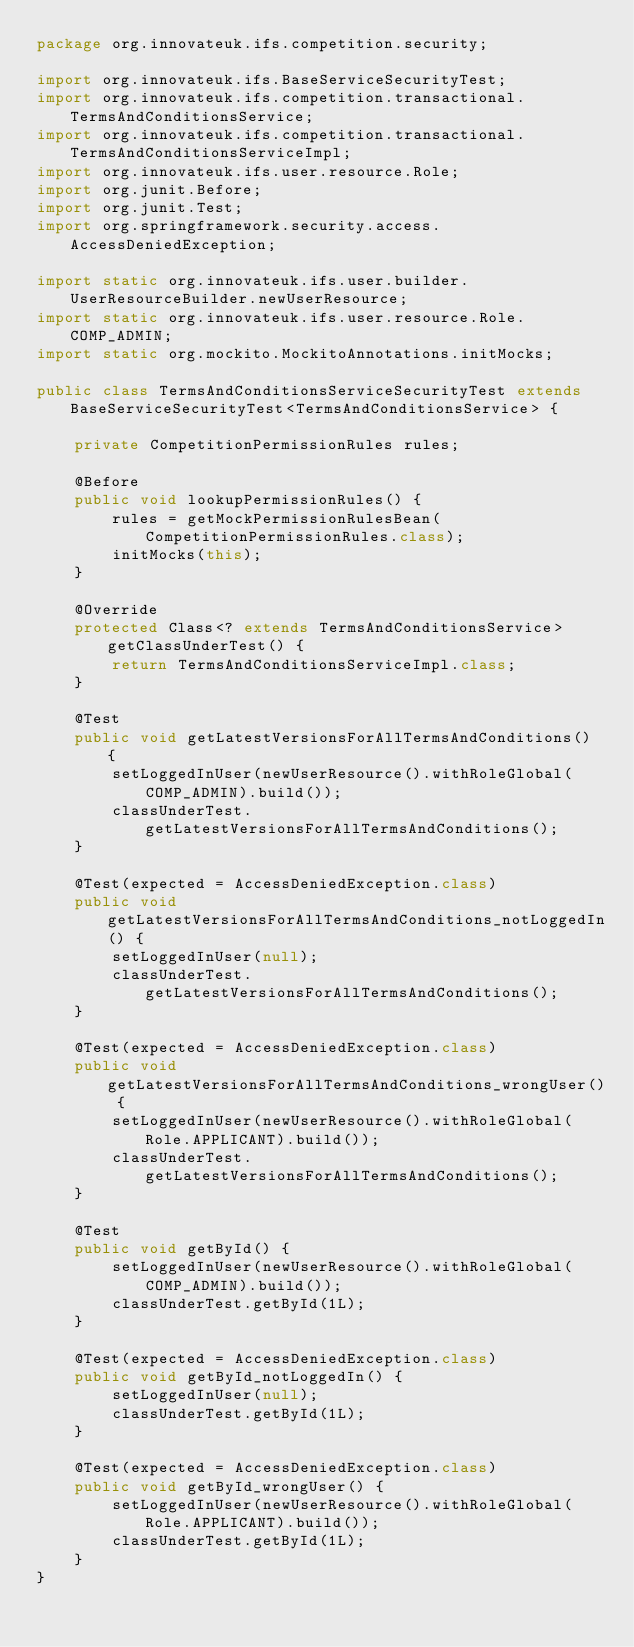<code> <loc_0><loc_0><loc_500><loc_500><_Java_>package org.innovateuk.ifs.competition.security;

import org.innovateuk.ifs.BaseServiceSecurityTest;
import org.innovateuk.ifs.competition.transactional.TermsAndConditionsService;
import org.innovateuk.ifs.competition.transactional.TermsAndConditionsServiceImpl;
import org.innovateuk.ifs.user.resource.Role;
import org.junit.Before;
import org.junit.Test;
import org.springframework.security.access.AccessDeniedException;

import static org.innovateuk.ifs.user.builder.UserResourceBuilder.newUserResource;
import static org.innovateuk.ifs.user.resource.Role.COMP_ADMIN;
import static org.mockito.MockitoAnnotations.initMocks;

public class TermsAndConditionsServiceSecurityTest extends BaseServiceSecurityTest<TermsAndConditionsService> {

    private CompetitionPermissionRules rules;

    @Before
    public void lookupPermissionRules() {
        rules = getMockPermissionRulesBean(CompetitionPermissionRules.class);
        initMocks(this);
    }

    @Override
    protected Class<? extends TermsAndConditionsService> getClassUnderTest() {
        return TermsAndConditionsServiceImpl.class;
    }

    @Test
    public void getLatestVersionsForAllTermsAndConditions() {
        setLoggedInUser(newUserResource().withRoleGlobal(COMP_ADMIN).build());
        classUnderTest.getLatestVersionsForAllTermsAndConditions();
    }

    @Test(expected = AccessDeniedException.class)
    public void getLatestVersionsForAllTermsAndConditions_notLoggedIn() {
        setLoggedInUser(null);
        classUnderTest.getLatestVersionsForAllTermsAndConditions();
    }

    @Test(expected = AccessDeniedException.class)
    public void getLatestVersionsForAllTermsAndConditions_wrongUser() {
        setLoggedInUser(newUserResource().withRoleGlobal(Role.APPLICANT).build());
        classUnderTest.getLatestVersionsForAllTermsAndConditions();
    }

    @Test
    public void getById() {
        setLoggedInUser(newUserResource().withRoleGlobal(COMP_ADMIN).build());
        classUnderTest.getById(1L);
    }

    @Test(expected = AccessDeniedException.class)
    public void getById_notLoggedIn() {
        setLoggedInUser(null);
        classUnderTest.getById(1L);
    }

    @Test(expected = AccessDeniedException.class)
    public void getById_wrongUser() {
        setLoggedInUser(newUserResource().withRoleGlobal(Role.APPLICANT).build());
        classUnderTest.getById(1L);
    }
}
</code> 